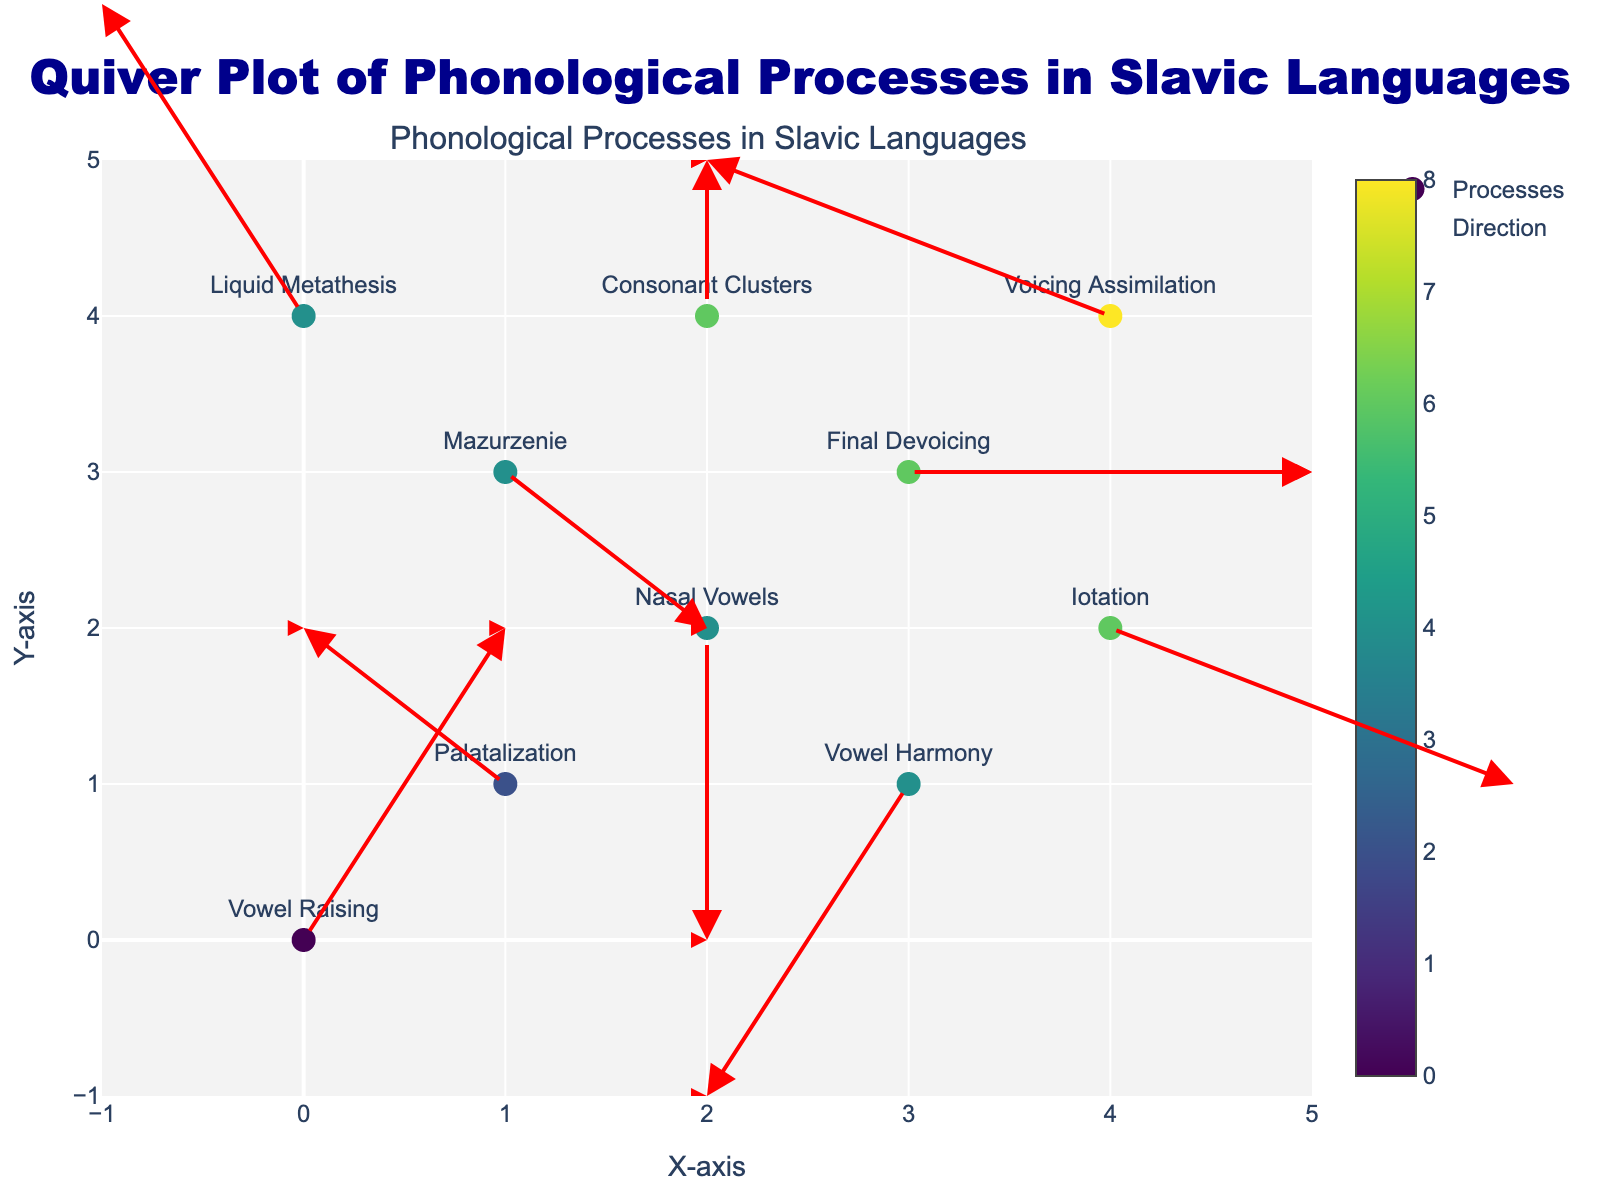What is the title of the figure? The title is usually located at the top of the figure. By reading it, we can determine the subject of the plot.
Answer: Quiver Plot of Phonological Processes in Slavic Languages How many phonological processes are illustrated in the figure? By counting the number of unique processes labeled on the plot, we determine the total number of processes.
Answer: 10 Which phonological process has the largest arrow vector (u, v)? To find this, we have to calculate the magnitude of each vector (u, v). The process with the largest magnitude is the one with the greatest influence. For instance, magnitude can be calculated as √(u^2 + v^2). The largest vector is (1, 2) for Vowel Raising.
Answer: Vowel Raising What are the coordinates where the Consonant Clusters process starts? Look at the markers' positions and locate the point labeled with the Consonant Clusters process. The coordinates will be the ones attached to that label.
Answer: (2, 4) Which phonological process moves from coordinates (4, 4)? Find the marker located at (4, 4) and check the label of the process starting from that point.
Answer: Voicing Assimilation Which phonological process results in the movement of 2 units to the right along the x-axis? Identify the arrow vectors with an x-component (u) equal to 2. Check the process label associated with that vector. The vectors are (2, 0) and (2, -1), so the processes are Final Devoicing and Iotation.
Answer: Final Devoicing, Iotation Are there any phonological processes with vectors pointing downwards (negative y-component)? If so, name them. Look for the arrows with a negative y-component in the vector (v). For instance, vectors (0, -2) and (-1, -2) have negative y-components. The processes associated with these vectors are Nasal Vowels and Vowel Harmony.
Answer: Nasal Vowels, Vowel Harmony What is the end coordinate for the Mazurzenie process? The Mazurzenie process starts at (1, 3) and moves according to the vector (1, -1). To find the end coordinate, add the vector to the starting point: (1+1, 3-1) = (2, 2).
Answer: (2, 2) Which phonological process starts at the top-left corner of the figure? Examine the starting points of the processes and identify the one positioned at the top-left corner (0, 0).
Answer: Vowel Raising Compare Vowel Harmony and Liquid Metathesis vectors: which has a larger horizontal component? Checking the vectors, Vowel Harmony has components (-1, -2) and Liquid Metathesis has components (-1, 2). Both have the same horizontal component magnitude of -1.
Answer: Both are the same 